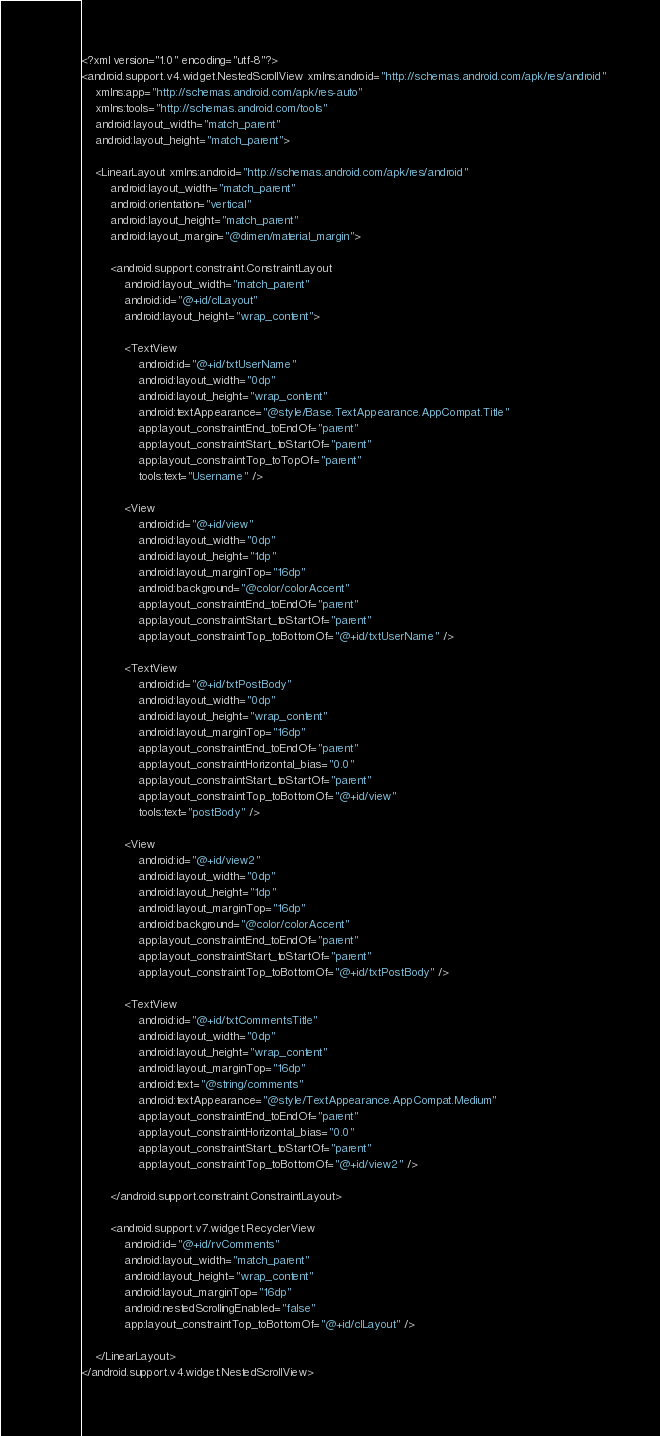Convert code to text. <code><loc_0><loc_0><loc_500><loc_500><_XML_><?xml version="1.0" encoding="utf-8"?>
<android.support.v4.widget.NestedScrollView xmlns:android="http://schemas.android.com/apk/res/android"
    xmlns:app="http://schemas.android.com/apk/res-auto"
    xmlns:tools="http://schemas.android.com/tools"
    android:layout_width="match_parent"
    android:layout_height="match_parent">

    <LinearLayout xmlns:android="http://schemas.android.com/apk/res/android"
        android:layout_width="match_parent"
        android:orientation="vertical"
        android:layout_height="match_parent"
        android:layout_margin="@dimen/material_margin">

        <android.support.constraint.ConstraintLayout
            android:layout_width="match_parent"
            android:id="@+id/clLayout"
            android:layout_height="wrap_content">

            <TextView
                android:id="@+id/txtUserName"
                android:layout_width="0dp"
                android:layout_height="wrap_content"
                android:textAppearance="@style/Base.TextAppearance.AppCompat.Title"
                app:layout_constraintEnd_toEndOf="parent"
                app:layout_constraintStart_toStartOf="parent"
                app:layout_constraintTop_toTopOf="parent"
                tools:text="Username" />

            <View
                android:id="@+id/view"
                android:layout_width="0dp"
                android:layout_height="1dp"
                android:layout_marginTop="16dp"
                android:background="@color/colorAccent"
                app:layout_constraintEnd_toEndOf="parent"
                app:layout_constraintStart_toStartOf="parent"
                app:layout_constraintTop_toBottomOf="@+id/txtUserName" />

            <TextView
                android:id="@+id/txtPostBody"
                android:layout_width="0dp"
                android:layout_height="wrap_content"
                android:layout_marginTop="16dp"
                app:layout_constraintEnd_toEndOf="parent"
                app:layout_constraintHorizontal_bias="0.0"
                app:layout_constraintStart_toStartOf="parent"
                app:layout_constraintTop_toBottomOf="@+id/view"
                tools:text="postBody" />

            <View
                android:id="@+id/view2"
                android:layout_width="0dp"
                android:layout_height="1dp"
                android:layout_marginTop="16dp"
                android:background="@color/colorAccent"
                app:layout_constraintEnd_toEndOf="parent"
                app:layout_constraintStart_toStartOf="parent"
                app:layout_constraintTop_toBottomOf="@+id/txtPostBody" />

            <TextView
                android:id="@+id/txtCommentsTitle"
                android:layout_width="0dp"
                android:layout_height="wrap_content"
                android:layout_marginTop="16dp"
                android:text="@string/comments"
                android:textAppearance="@style/TextAppearance.AppCompat.Medium"
                app:layout_constraintEnd_toEndOf="parent"
                app:layout_constraintHorizontal_bias="0.0"
                app:layout_constraintStart_toStartOf="parent"
                app:layout_constraintTop_toBottomOf="@+id/view2" />

        </android.support.constraint.ConstraintLayout>

        <android.support.v7.widget.RecyclerView
            android:id="@+id/rvComments"
            android:layout_width="match_parent"
            android:layout_height="wrap_content"
            android:layout_marginTop="16dp"
            android:nestedScrollingEnabled="false"
            app:layout_constraintTop_toBottomOf="@+id/clLayout" />

    </LinearLayout>
</android.support.v4.widget.NestedScrollView></code> 